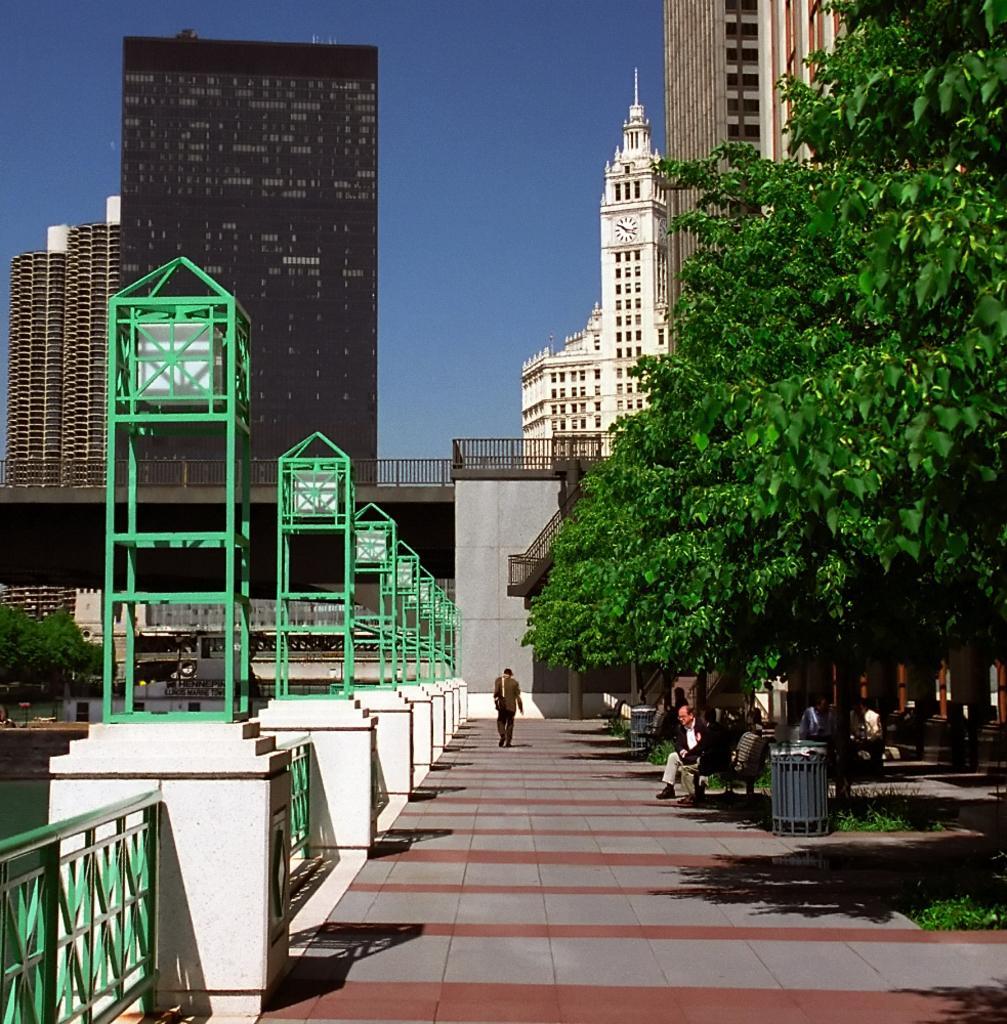Describe this image in one or two sentences. In this image we can see there is a person walking on the path. On the right side of the image there are some trees, under the trees there are some benches and a few people are sitting on the bench. On the left side of the image there is a lake and fencing. In the background of the image there are some buildings and sky. 